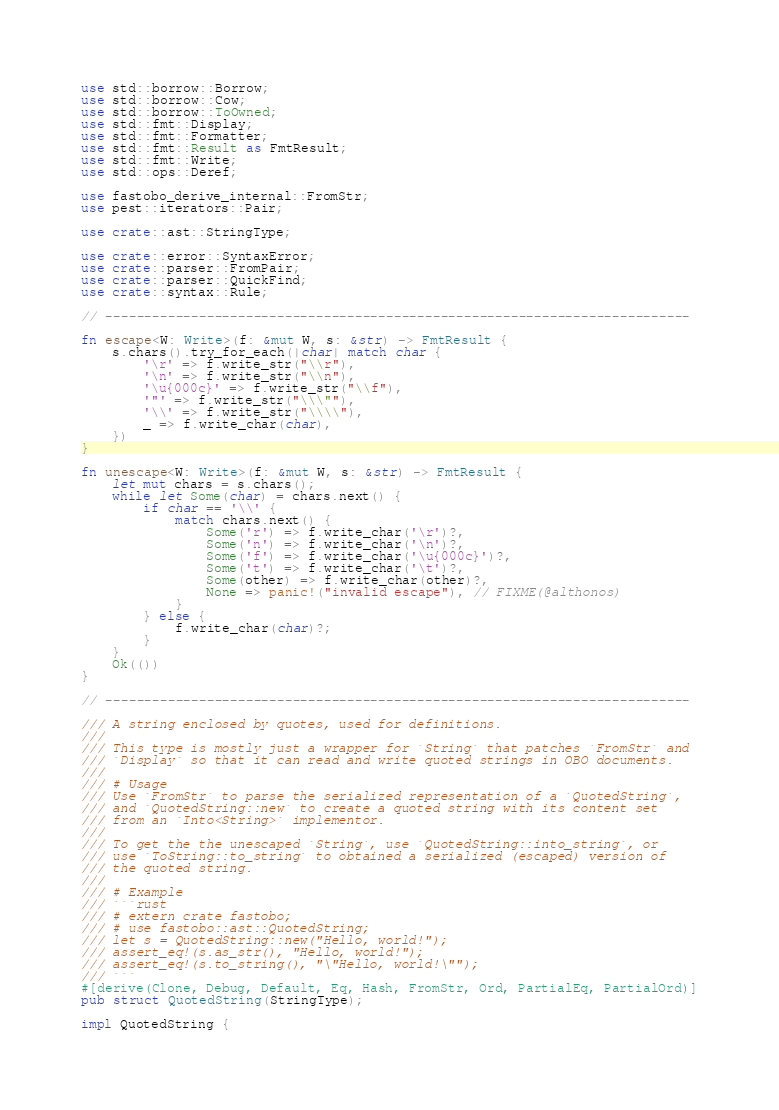Convert code to text. <code><loc_0><loc_0><loc_500><loc_500><_Rust_>use std::borrow::Borrow;
use std::borrow::Cow;
use std::borrow::ToOwned;
use std::fmt::Display;
use std::fmt::Formatter;
use std::fmt::Result as FmtResult;
use std::fmt::Write;
use std::ops::Deref;

use fastobo_derive_internal::FromStr;
use pest::iterators::Pair;

use crate::ast::StringType;

use crate::error::SyntaxError;
use crate::parser::FromPair;
use crate::parser::QuickFind;
use crate::syntax::Rule;

// ---------------------------------------------------------------------------

fn escape<W: Write>(f: &mut W, s: &str) -> FmtResult {
    s.chars().try_for_each(|char| match char {
        '\r' => f.write_str("\\r"),
        '\n' => f.write_str("\\n"),
        '\u{000c}' => f.write_str("\\f"),
        '"' => f.write_str("\\\""),
        '\\' => f.write_str("\\\\"),
        _ => f.write_char(char),
    })
}

fn unescape<W: Write>(f: &mut W, s: &str) -> FmtResult {
    let mut chars = s.chars();
    while let Some(char) = chars.next() {
        if char == '\\' {
            match chars.next() {
                Some('r') => f.write_char('\r')?,
                Some('n') => f.write_char('\n')?,
                Some('f') => f.write_char('\u{000c}')?,
                Some('t') => f.write_char('\t')?,
                Some(other) => f.write_char(other)?,
                None => panic!("invalid escape"), // FIXME(@althonos)
            }
        } else {
            f.write_char(char)?;
        }
    }
    Ok(())
}

// ---------------------------------------------------------------------------

/// A string enclosed by quotes, used for definitions.
///
/// This type is mostly just a wrapper for `String` that patches `FromStr` and
/// `Display` so that it can read and write quoted strings in OBO documents.
///
/// # Usage
/// Use `FromStr` to parse the serialized representation of a `QuotedString`,
/// and `QuotedString::new` to create a quoted string with its content set
/// from an `Into<String>` implementor.
///
/// To get the the unescaped `String`, use `QuotedString::into_string`, or
/// use `ToString::to_string` to obtained a serialized (escaped) version of
/// the quoted string.
///
/// # Example
/// ```rust
/// # extern crate fastobo;
/// # use fastobo::ast::QuotedString;
/// let s = QuotedString::new("Hello, world!");
/// assert_eq!(s.as_str(), "Hello, world!");
/// assert_eq!(s.to_string(), "\"Hello, world!\"");
/// ```
#[derive(Clone, Debug, Default, Eq, Hash, FromStr, Ord, PartialEq, PartialOrd)]
pub struct QuotedString(StringType);

impl QuotedString {</code> 